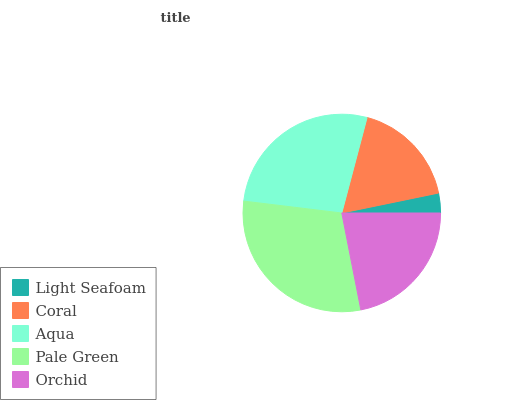Is Light Seafoam the minimum?
Answer yes or no. Yes. Is Pale Green the maximum?
Answer yes or no. Yes. Is Coral the minimum?
Answer yes or no. No. Is Coral the maximum?
Answer yes or no. No. Is Coral greater than Light Seafoam?
Answer yes or no. Yes. Is Light Seafoam less than Coral?
Answer yes or no. Yes. Is Light Seafoam greater than Coral?
Answer yes or no. No. Is Coral less than Light Seafoam?
Answer yes or no. No. Is Orchid the high median?
Answer yes or no. Yes. Is Orchid the low median?
Answer yes or no. Yes. Is Light Seafoam the high median?
Answer yes or no. No. Is Light Seafoam the low median?
Answer yes or no. No. 